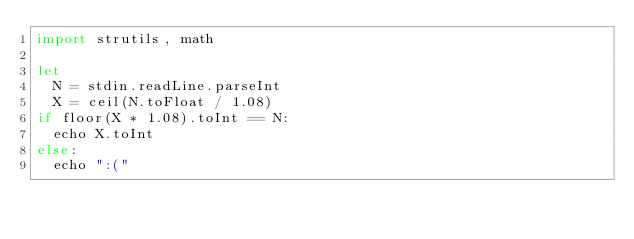Convert code to text. <code><loc_0><loc_0><loc_500><loc_500><_Nim_>import strutils, math

let
  N = stdin.readLine.parseInt
  X = ceil(N.toFloat / 1.08)
if floor(X * 1.08).toInt == N:
  echo X.toInt
else:
  echo ":("
</code> 